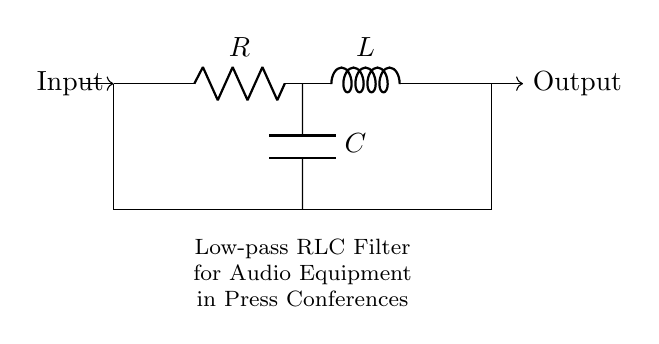What is the type of filter represented by this circuit? The circuit is configured as a low-pass filter, which allows low-frequency signals to pass while attenuating high-frequency signals. The presence of the resistor, inductor, and capacitor indicates that it is designed to filter frequencies based on their impedance characteristics.
Answer: Low-pass filter What components are present in the circuit? The circuit diagram shows three main components: a resistor (R), an inductor (L), and a capacitor (C). These components are arranged in a specific configuration that defines the behavior of the filter.
Answer: Resistor, Inductor, Capacitor What is the purpose of the capacitor in this circuit? In a low-pass RLC filter, the capacitor serves to block high-frequency signals due to its reactance increasing at higher frequencies. This allows it to effectively attenuate these frequencies while allowing lower frequencies to pass through, contributing to the filtering action.
Answer: Attenuate high-frequency signals How does the inductor affect the circuit's performance? The inductor opposes changes in current and presents a lower impedance at low frequencies. This property allows low-frequency signals to pass while providing higher impedance to high-frequency signals, thus playing a significant role in the low-pass filtering functionality.
Answer: Opposes high-frequency signals What is the expected output of this circuit for a low-frequency signal? For low-frequency signals, the output will closely match the input since both the resistor and inductor allow such frequencies to pass through with minimal attenuation, resulting in high signal fidelity.
Answer: Similar to input What type of load would this filter typically serve? This low-pass RLC filter is typically used in audio equipment, particularly for applications requiring the filtering of audio signals to eliminate high-frequency noise, thus enhancing sound quality.
Answer: Audio equipment What configuration connects these components? The components are connected in a series configuration where the output is taken across the capacitor, representing a standard low-pass RLC filter design. This arrangement ensures effective filtering of unwanted frequencies.
Answer: Series configuration 